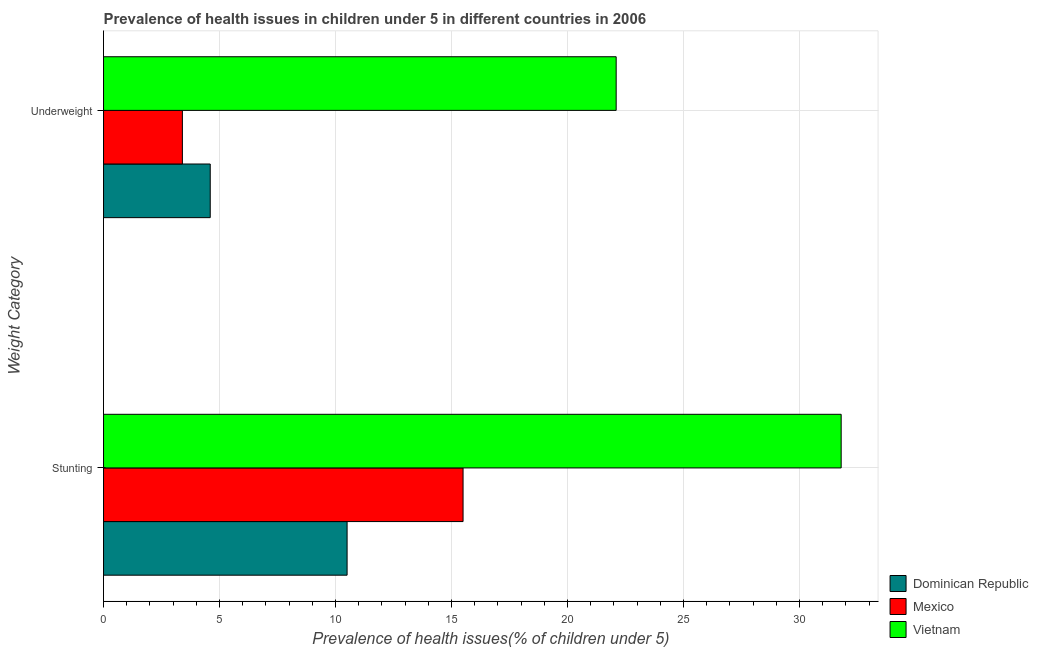How many different coloured bars are there?
Keep it short and to the point. 3. How many groups of bars are there?
Ensure brevity in your answer.  2. What is the label of the 1st group of bars from the top?
Provide a short and direct response. Underweight. Across all countries, what is the maximum percentage of underweight children?
Provide a succinct answer. 22.1. Across all countries, what is the minimum percentage of underweight children?
Offer a terse response. 3.4. In which country was the percentage of stunted children maximum?
Make the answer very short. Vietnam. In which country was the percentage of stunted children minimum?
Keep it short and to the point. Dominican Republic. What is the total percentage of stunted children in the graph?
Make the answer very short. 57.8. What is the difference between the percentage of stunted children in Dominican Republic and that in Vietnam?
Provide a short and direct response. -21.3. What is the difference between the percentage of stunted children in Mexico and the percentage of underweight children in Vietnam?
Offer a terse response. -6.6. What is the average percentage of underweight children per country?
Provide a short and direct response. 10.03. What is the difference between the percentage of stunted children and percentage of underweight children in Mexico?
Offer a very short reply. 12.1. In how many countries, is the percentage of underweight children greater than 16 %?
Your response must be concise. 1. What is the ratio of the percentage of underweight children in Vietnam to that in Dominican Republic?
Offer a very short reply. 4.8. Is the percentage of stunted children in Mexico less than that in Vietnam?
Keep it short and to the point. Yes. In how many countries, is the percentage of stunted children greater than the average percentage of stunted children taken over all countries?
Provide a short and direct response. 1. What does the 2nd bar from the top in Underweight represents?
Your answer should be very brief. Mexico. What does the 1st bar from the bottom in Stunting represents?
Your answer should be very brief. Dominican Republic. How many bars are there?
Provide a succinct answer. 6. Are all the bars in the graph horizontal?
Provide a short and direct response. Yes. How many countries are there in the graph?
Make the answer very short. 3. What is the difference between two consecutive major ticks on the X-axis?
Keep it short and to the point. 5. Does the graph contain any zero values?
Make the answer very short. No. How many legend labels are there?
Provide a succinct answer. 3. How are the legend labels stacked?
Make the answer very short. Vertical. What is the title of the graph?
Your answer should be compact. Prevalence of health issues in children under 5 in different countries in 2006. What is the label or title of the X-axis?
Provide a succinct answer. Prevalence of health issues(% of children under 5). What is the label or title of the Y-axis?
Give a very brief answer. Weight Category. What is the Prevalence of health issues(% of children under 5) in Mexico in Stunting?
Provide a short and direct response. 15.5. What is the Prevalence of health issues(% of children under 5) in Vietnam in Stunting?
Your answer should be compact. 31.8. What is the Prevalence of health issues(% of children under 5) of Dominican Republic in Underweight?
Your response must be concise. 4.6. What is the Prevalence of health issues(% of children under 5) of Mexico in Underweight?
Ensure brevity in your answer.  3.4. What is the Prevalence of health issues(% of children under 5) in Vietnam in Underweight?
Provide a short and direct response. 22.1. Across all Weight Category, what is the maximum Prevalence of health issues(% of children under 5) of Dominican Republic?
Offer a very short reply. 10.5. Across all Weight Category, what is the maximum Prevalence of health issues(% of children under 5) in Mexico?
Provide a succinct answer. 15.5. Across all Weight Category, what is the maximum Prevalence of health issues(% of children under 5) of Vietnam?
Provide a succinct answer. 31.8. Across all Weight Category, what is the minimum Prevalence of health issues(% of children under 5) of Dominican Republic?
Give a very brief answer. 4.6. Across all Weight Category, what is the minimum Prevalence of health issues(% of children under 5) in Mexico?
Keep it short and to the point. 3.4. Across all Weight Category, what is the minimum Prevalence of health issues(% of children under 5) of Vietnam?
Your response must be concise. 22.1. What is the total Prevalence of health issues(% of children under 5) of Dominican Republic in the graph?
Your answer should be compact. 15.1. What is the total Prevalence of health issues(% of children under 5) of Mexico in the graph?
Give a very brief answer. 18.9. What is the total Prevalence of health issues(% of children under 5) of Vietnam in the graph?
Your answer should be compact. 53.9. What is the difference between the Prevalence of health issues(% of children under 5) of Dominican Republic in Stunting and that in Underweight?
Your answer should be compact. 5.9. What is the difference between the Prevalence of health issues(% of children under 5) of Vietnam in Stunting and that in Underweight?
Offer a very short reply. 9.7. What is the difference between the Prevalence of health issues(% of children under 5) in Dominican Republic in Stunting and the Prevalence of health issues(% of children under 5) in Mexico in Underweight?
Ensure brevity in your answer.  7.1. What is the average Prevalence of health issues(% of children under 5) of Dominican Republic per Weight Category?
Ensure brevity in your answer.  7.55. What is the average Prevalence of health issues(% of children under 5) of Mexico per Weight Category?
Your answer should be very brief. 9.45. What is the average Prevalence of health issues(% of children under 5) of Vietnam per Weight Category?
Offer a terse response. 26.95. What is the difference between the Prevalence of health issues(% of children under 5) in Dominican Republic and Prevalence of health issues(% of children under 5) in Vietnam in Stunting?
Ensure brevity in your answer.  -21.3. What is the difference between the Prevalence of health issues(% of children under 5) of Mexico and Prevalence of health issues(% of children under 5) of Vietnam in Stunting?
Your answer should be very brief. -16.3. What is the difference between the Prevalence of health issues(% of children under 5) of Dominican Republic and Prevalence of health issues(% of children under 5) of Mexico in Underweight?
Provide a succinct answer. 1.2. What is the difference between the Prevalence of health issues(% of children under 5) of Dominican Republic and Prevalence of health issues(% of children under 5) of Vietnam in Underweight?
Provide a succinct answer. -17.5. What is the difference between the Prevalence of health issues(% of children under 5) in Mexico and Prevalence of health issues(% of children under 5) in Vietnam in Underweight?
Give a very brief answer. -18.7. What is the ratio of the Prevalence of health issues(% of children under 5) of Dominican Republic in Stunting to that in Underweight?
Keep it short and to the point. 2.28. What is the ratio of the Prevalence of health issues(% of children under 5) of Mexico in Stunting to that in Underweight?
Your answer should be compact. 4.56. What is the ratio of the Prevalence of health issues(% of children under 5) of Vietnam in Stunting to that in Underweight?
Provide a succinct answer. 1.44. What is the difference between the highest and the second highest Prevalence of health issues(% of children under 5) of Vietnam?
Your answer should be compact. 9.7. What is the difference between the highest and the lowest Prevalence of health issues(% of children under 5) of Dominican Republic?
Give a very brief answer. 5.9. What is the difference between the highest and the lowest Prevalence of health issues(% of children under 5) of Mexico?
Your response must be concise. 12.1. What is the difference between the highest and the lowest Prevalence of health issues(% of children under 5) in Vietnam?
Offer a terse response. 9.7. 